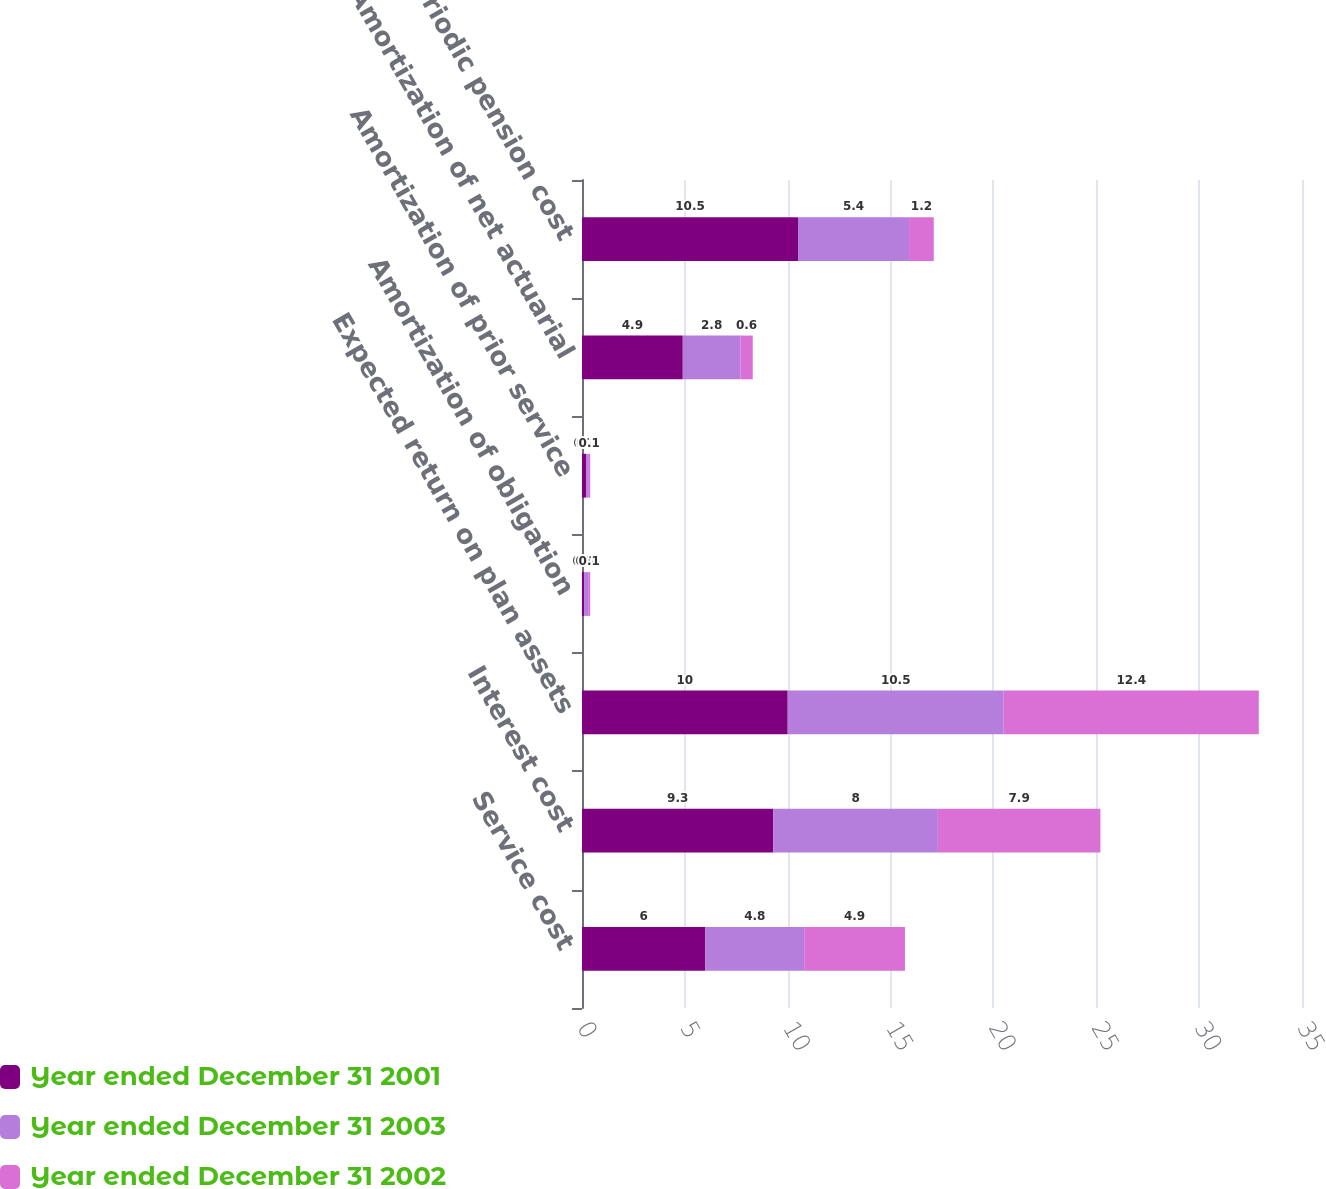Convert chart. <chart><loc_0><loc_0><loc_500><loc_500><stacked_bar_chart><ecel><fcel>Service cost<fcel>Interest cost<fcel>Expected return on plan assets<fcel>Amortization of obligation<fcel>Amortization of prior service<fcel>Amortization of net actuarial<fcel>Net periodic pension cost<nl><fcel>Year ended December 31 2001<fcel>6<fcel>9.3<fcel>10<fcel>0.1<fcel>0.2<fcel>4.9<fcel>10.5<nl><fcel>Year ended December 31 2003<fcel>4.8<fcel>8<fcel>10.5<fcel>0.2<fcel>0.1<fcel>2.8<fcel>5.4<nl><fcel>Year ended December 31 2002<fcel>4.9<fcel>7.9<fcel>12.4<fcel>0.1<fcel>0.1<fcel>0.6<fcel>1.2<nl></chart> 